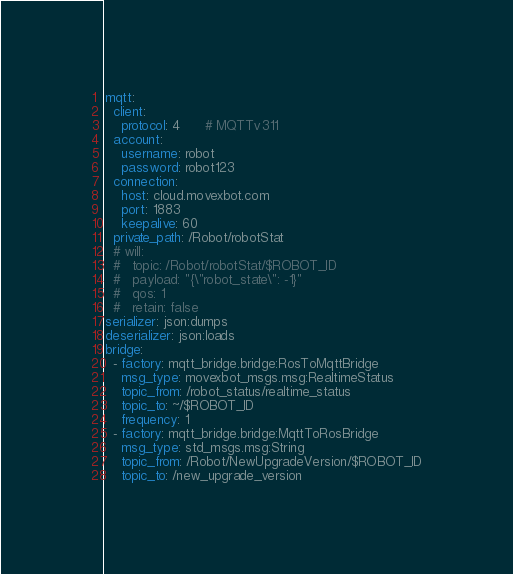<code> <loc_0><loc_0><loc_500><loc_500><_YAML_>mqtt:
  client:
    protocol: 4      # MQTTv311
  account:
    username: robot
    password: robot123
  connection:
    host: cloud.movexbot.com
    port: 1883
    keepalive: 60
  private_path: /Robot/robotStat
  # will:
  #   topic: /Robot/robotStat/$ROBOT_ID
  #   payload: "{\"robot_state\": -1}"
  #   qos: 1
  #   retain: false
serializer: json:dumps
deserializer: json:loads
bridge:
  - factory: mqtt_bridge.bridge:RosToMqttBridge
    msg_type: movexbot_msgs.msg:RealtimeStatus
    topic_from: /robot_status/realtime_status
    topic_to: ~/$ROBOT_ID
    frequency: 1
  - factory: mqtt_bridge.bridge:MqttToRosBridge
    msg_type: std_msgs.msg:String
    topic_from: /Robot/NewUpgradeVersion/$ROBOT_ID
    topic_to: /new_upgrade_version</code> 